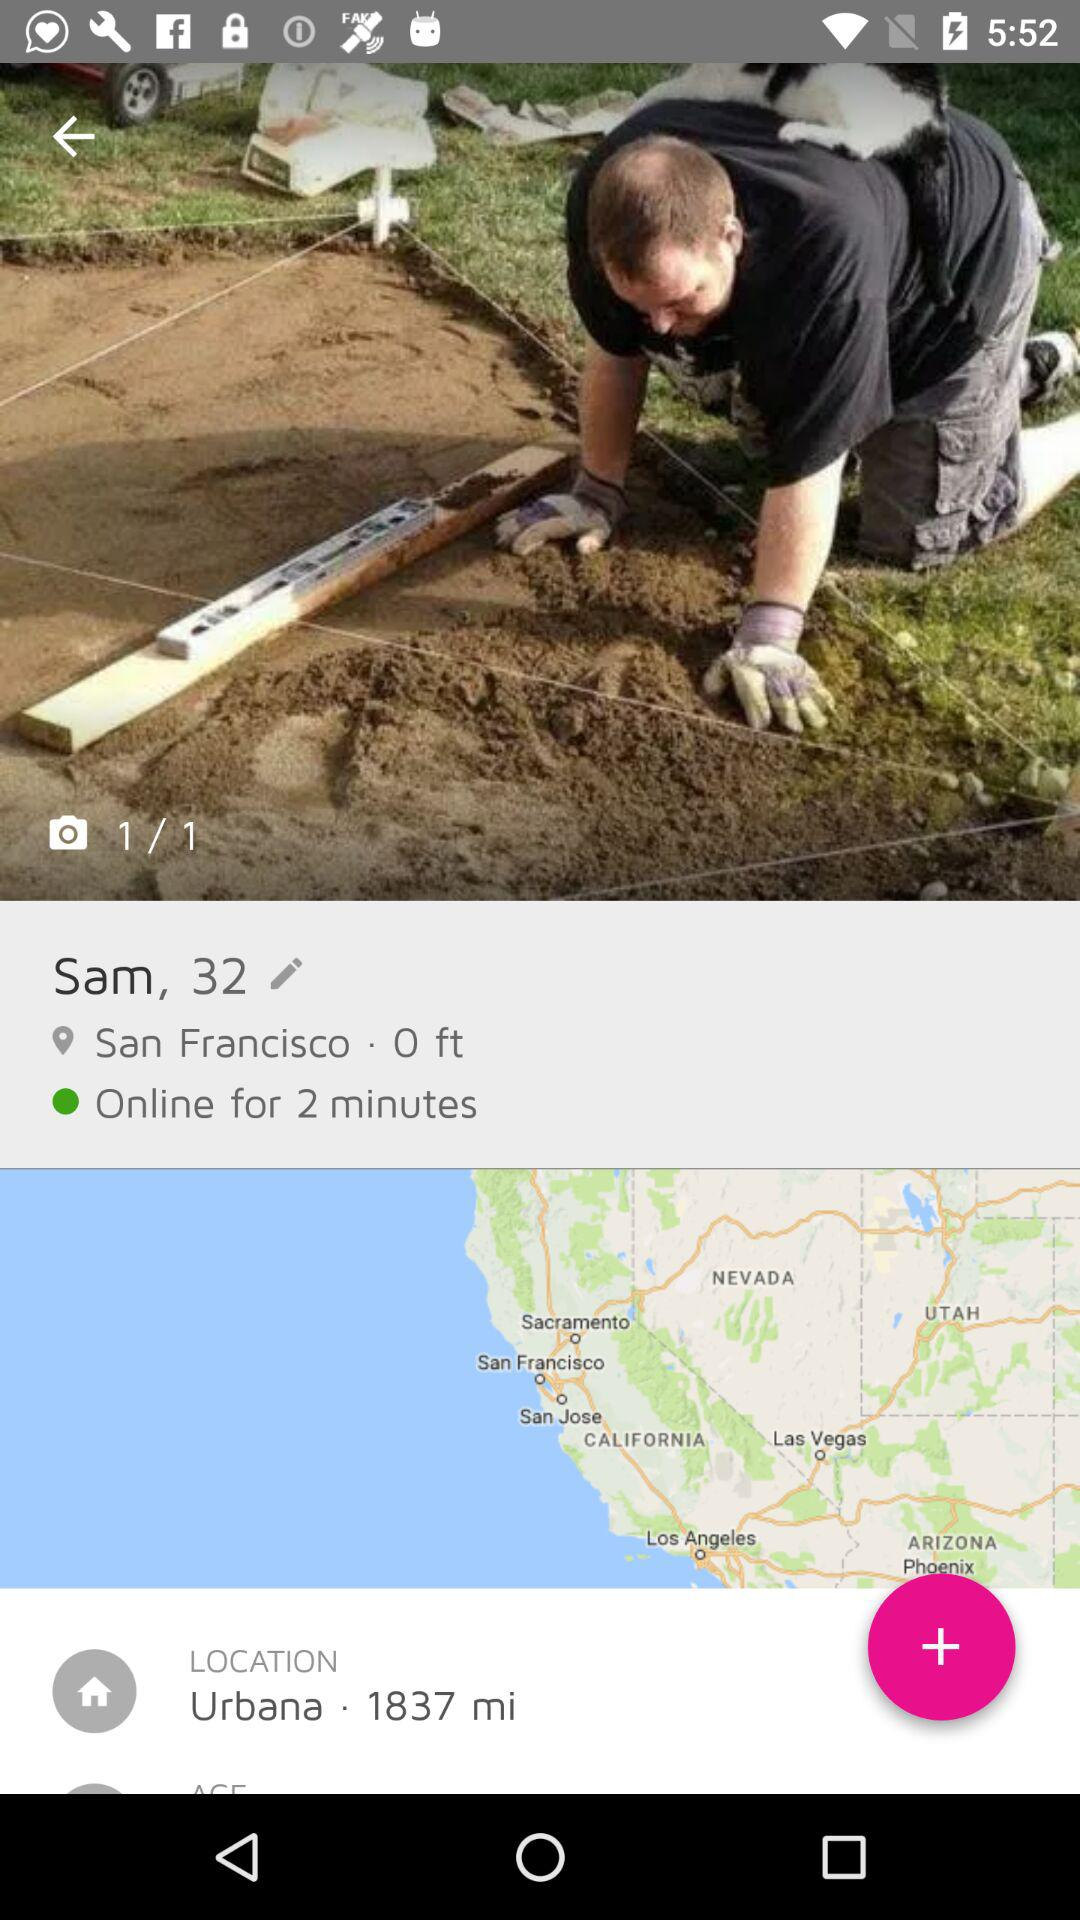How many total number of images are shown? The total number of shown images is 1. 